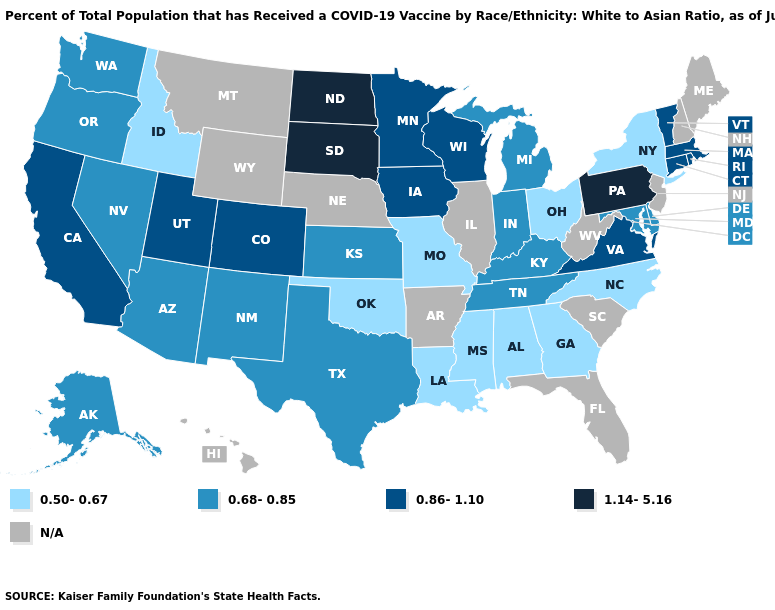What is the highest value in the MidWest ?
Be succinct. 1.14-5.16. What is the value of Tennessee?
Be succinct. 0.68-0.85. What is the value of Oregon?
Quick response, please. 0.68-0.85. Name the states that have a value in the range 0.50-0.67?
Write a very short answer. Alabama, Georgia, Idaho, Louisiana, Mississippi, Missouri, New York, North Carolina, Ohio, Oklahoma. What is the lowest value in states that border Virginia?
Be succinct. 0.50-0.67. What is the value of Nevada?
Keep it brief. 0.68-0.85. What is the value of South Dakota?
Keep it brief. 1.14-5.16. Among the states that border Washington , does Idaho have the highest value?
Give a very brief answer. No. Among the states that border Alabama , does Mississippi have the highest value?
Be succinct. No. Name the states that have a value in the range 0.68-0.85?
Quick response, please. Alaska, Arizona, Delaware, Indiana, Kansas, Kentucky, Maryland, Michigan, Nevada, New Mexico, Oregon, Tennessee, Texas, Washington. What is the value of South Dakota?
Keep it brief. 1.14-5.16. Name the states that have a value in the range 0.50-0.67?
Give a very brief answer. Alabama, Georgia, Idaho, Louisiana, Mississippi, Missouri, New York, North Carolina, Ohio, Oklahoma. What is the highest value in the South ?
Quick response, please. 0.86-1.10. Which states have the highest value in the USA?
Answer briefly. North Dakota, Pennsylvania, South Dakota. What is the highest value in states that border Nevada?
Concise answer only. 0.86-1.10. 